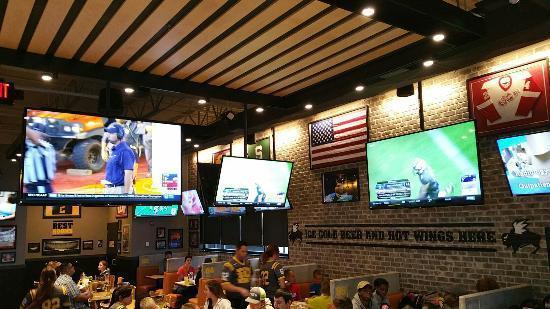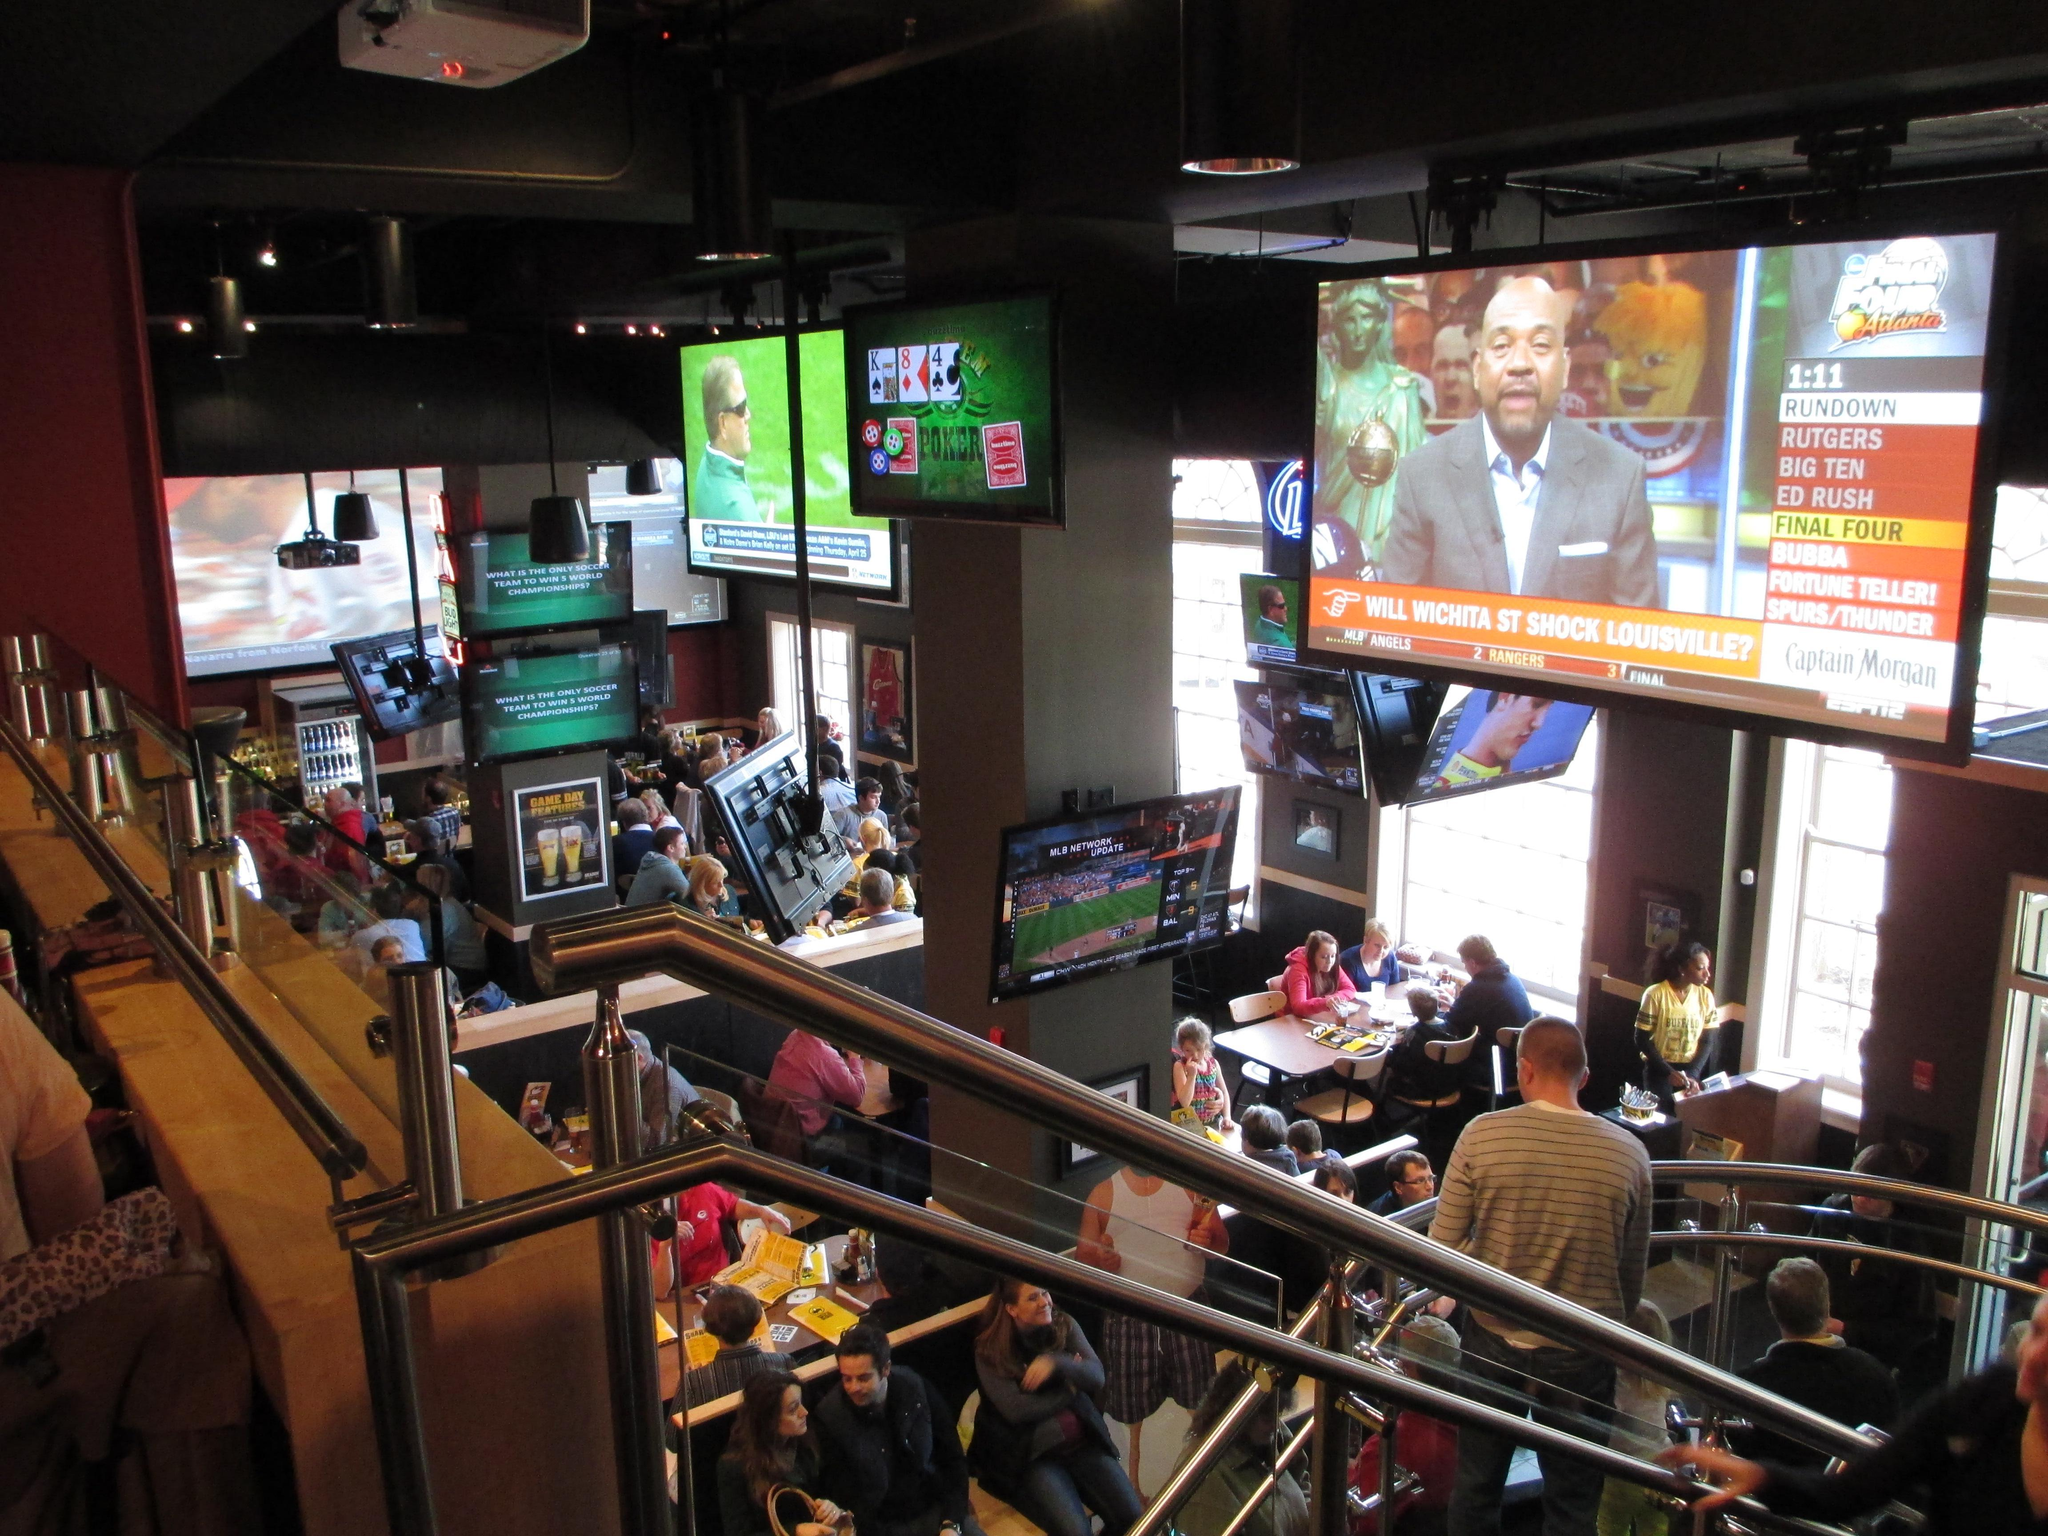The first image is the image on the left, the second image is the image on the right. Given the left and right images, does the statement "A yellow wall can be seen in the background of the left image." hold true? Answer yes or no. No. 